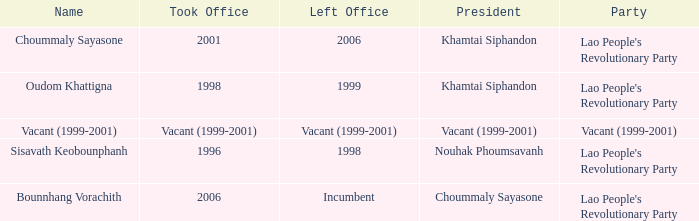What is Left Office, when Party is Vacant (1999-2001)? Vacant (1999-2001). 